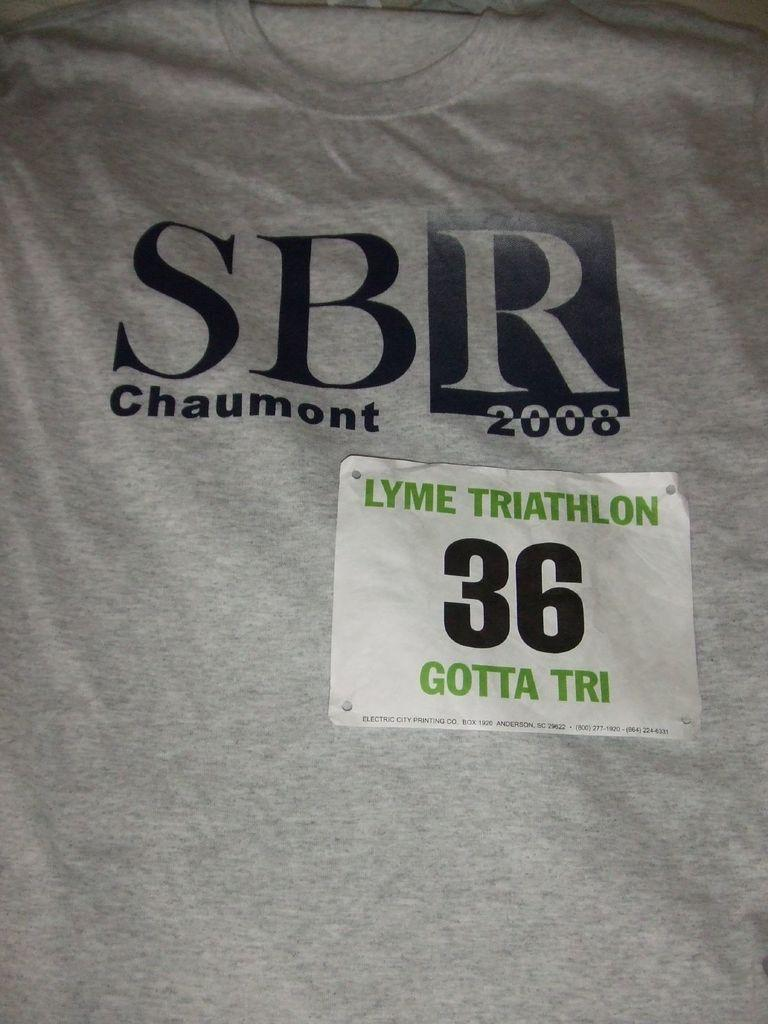What type of text can be seen on the shirt in the image? There are numbers, alphabets, and words on the shirt. What is the color of the shirt in the image? The shirt is grey in color. How many buildings are visible on the shirt in the image? There are no buildings visible on the shirt in the image. What type of adjustment can be made to the angle of the shirt in the image? The angle of the shirt in the image cannot be adjusted, as it is a static image. 